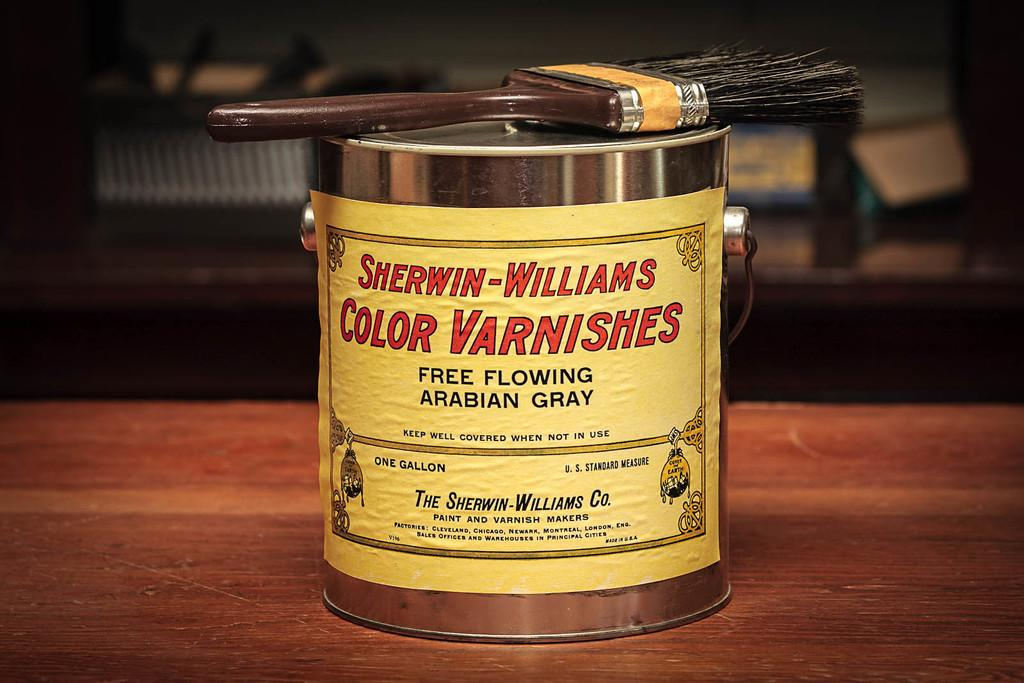<image>
Render a clear and concise summary of the photo. A can of Swerwin-Williams Color Varnishes in the color of Arabian Gray 